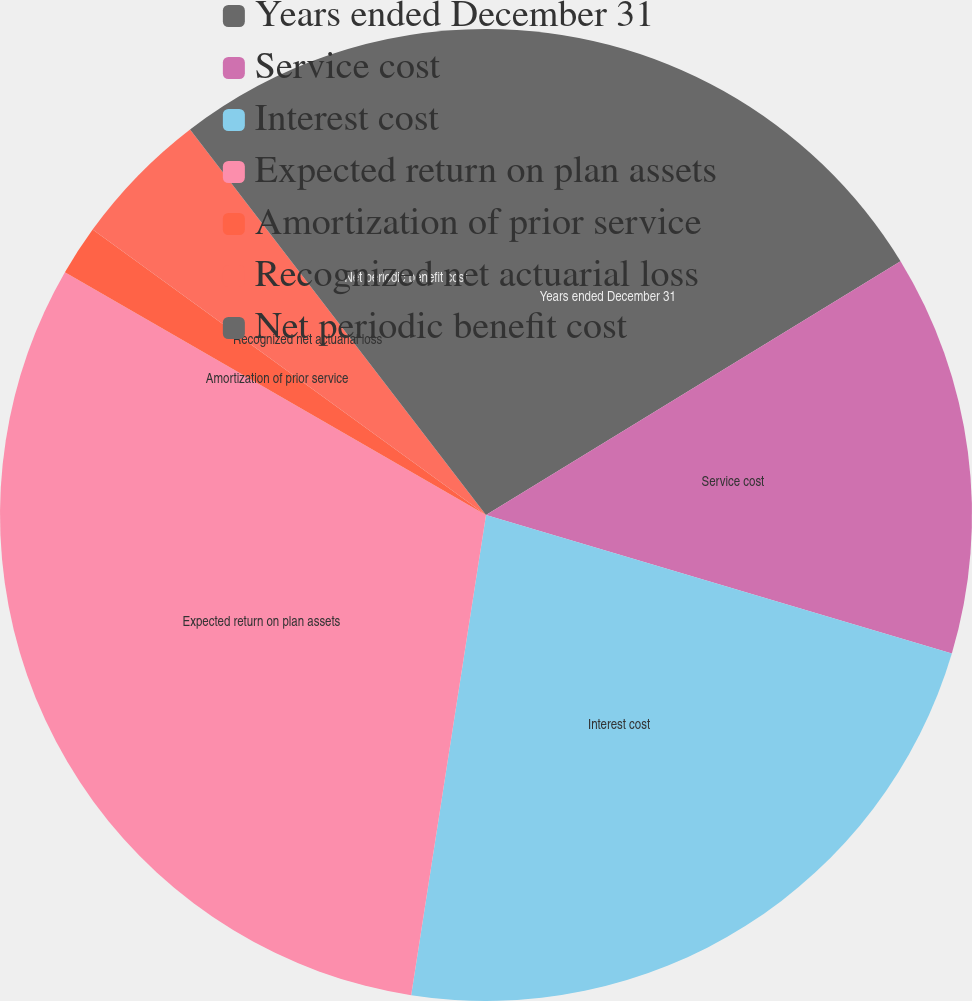<chart> <loc_0><loc_0><loc_500><loc_500><pie_chart><fcel>Years ended December 31<fcel>Service cost<fcel>Interest cost<fcel>Expected return on plan assets<fcel>Amortization of prior service<fcel>Recognized net actuarial loss<fcel>Net periodic benefit cost<nl><fcel>16.26%<fcel>13.34%<fcel>22.86%<fcel>30.86%<fcel>1.67%<fcel>4.59%<fcel>10.42%<nl></chart> 